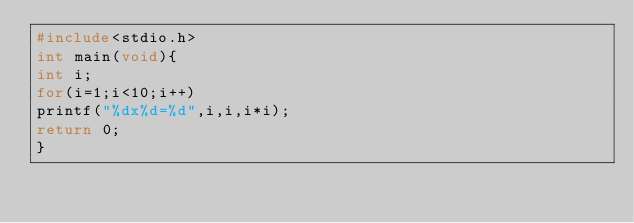<code> <loc_0><loc_0><loc_500><loc_500><_C_>#include<stdio.h>
int main(void){
int i;
for(i=1;i<10;i++)
printf("%dx%d=%d",i,i,i*i);
return 0;
}</code> 